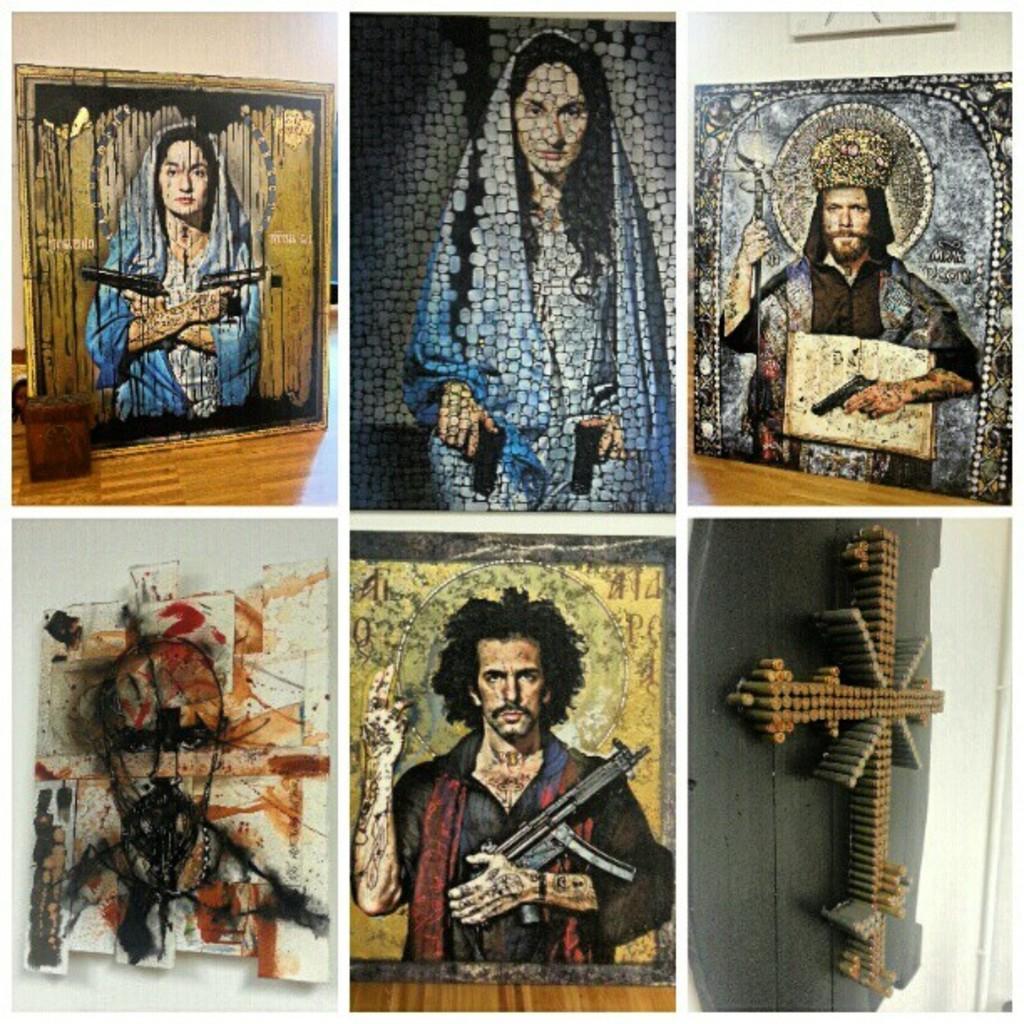Can you describe this image briefly? In the picture we can see some paintings of two men and two women and a cross. 